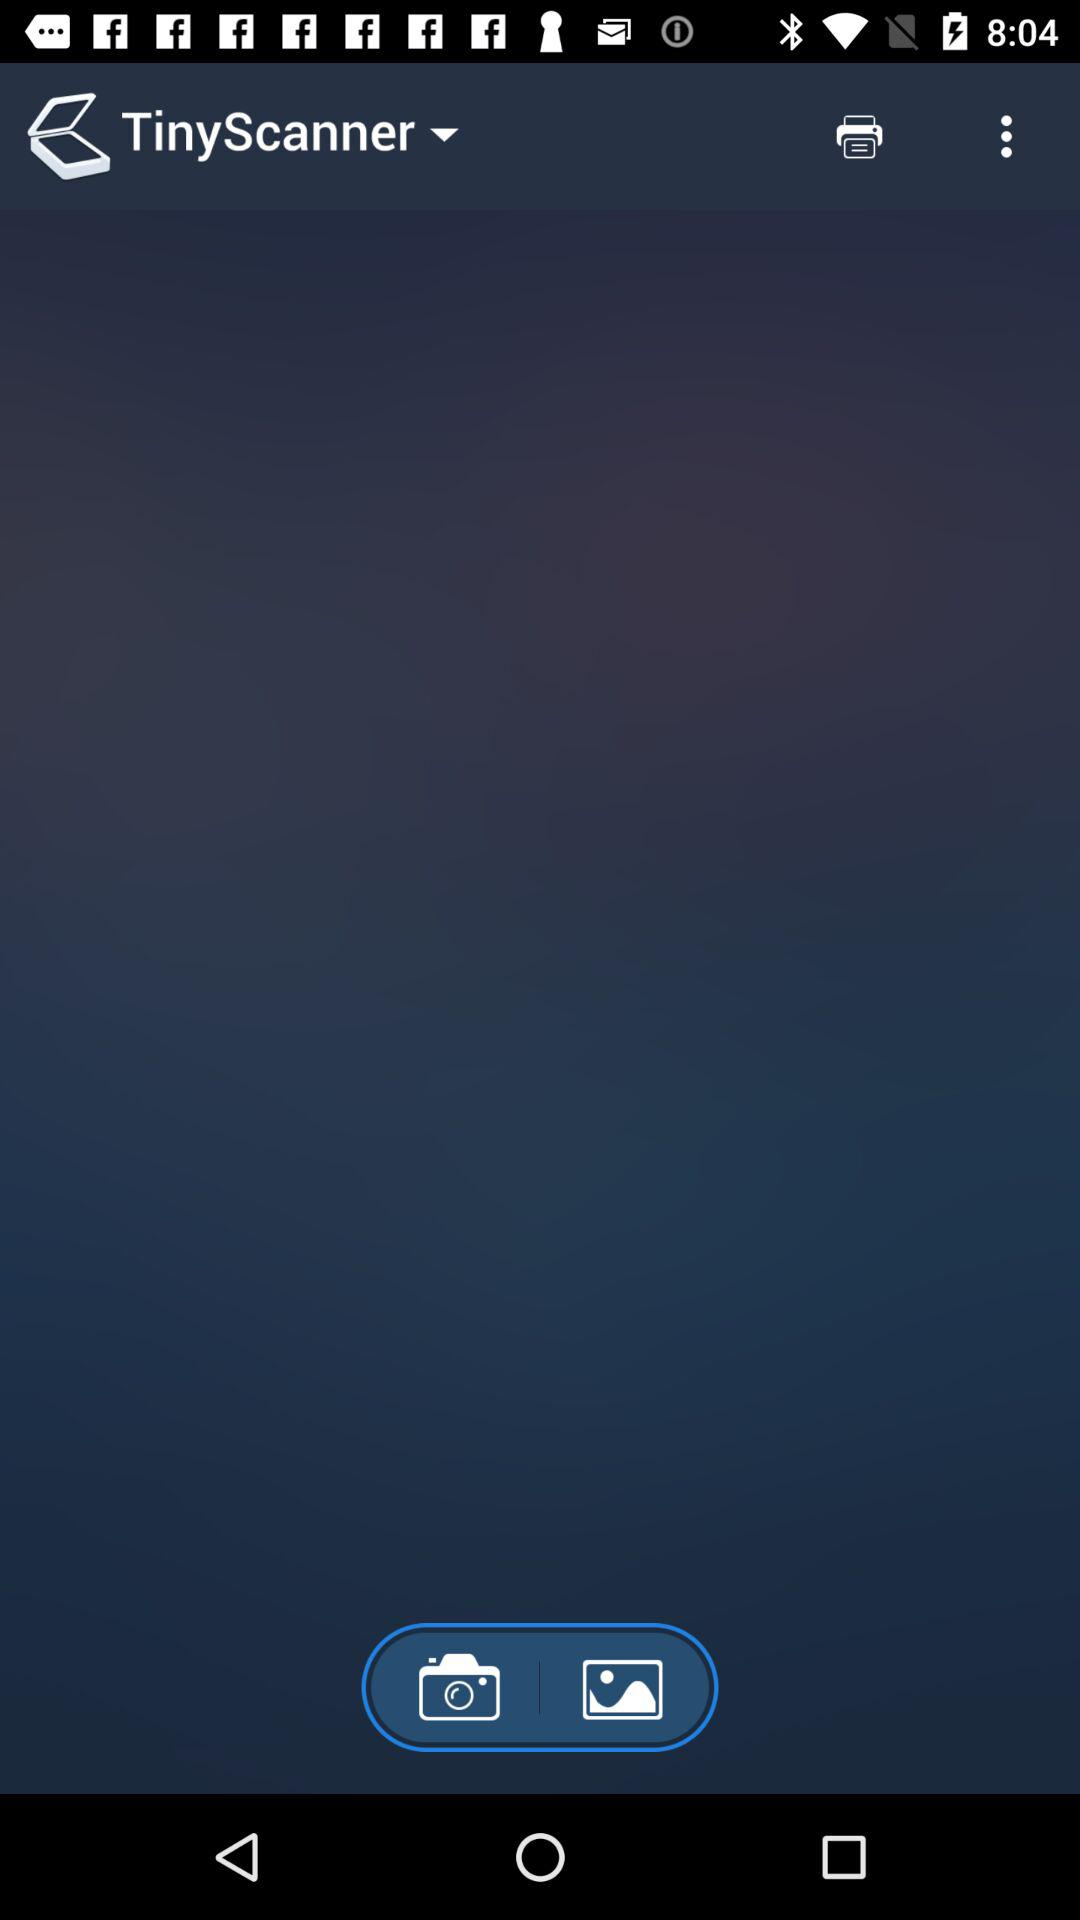What is the application name? The application name is "TinyScanner". 